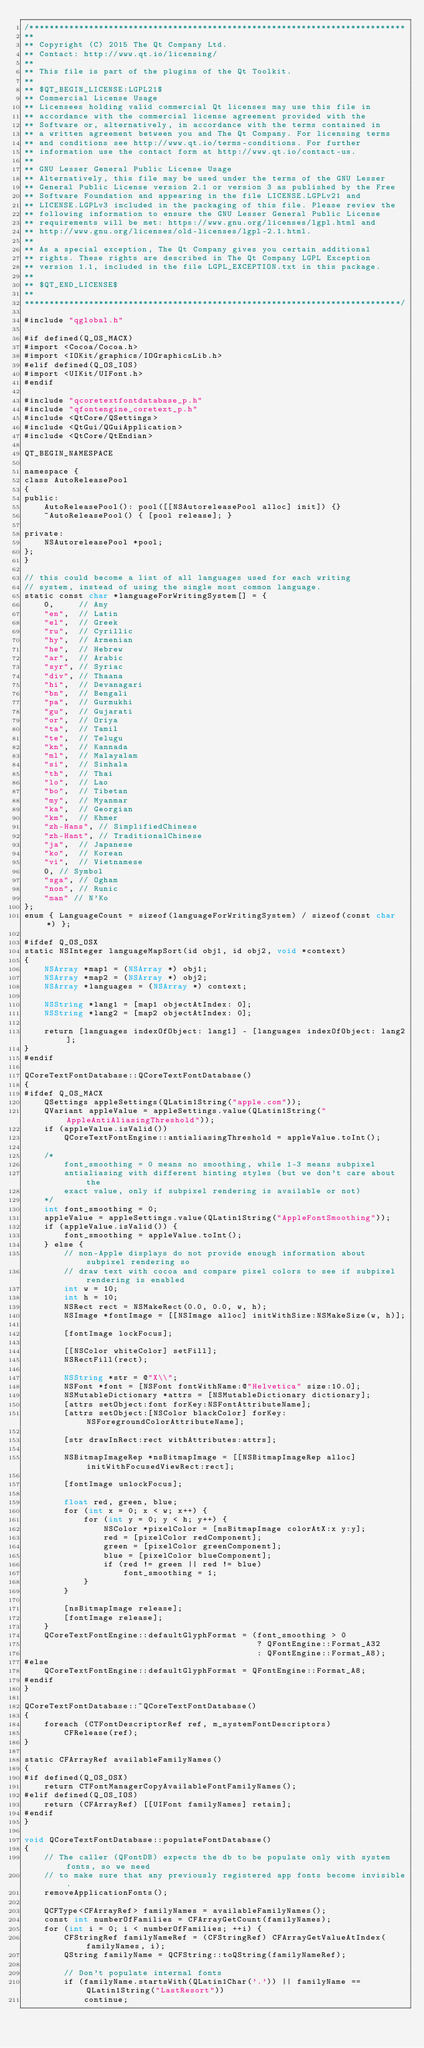Convert code to text. <code><loc_0><loc_0><loc_500><loc_500><_ObjectiveC_>/****************************************************************************
**
** Copyright (C) 2015 The Qt Company Ltd.
** Contact: http://www.qt.io/licensing/
**
** This file is part of the plugins of the Qt Toolkit.
**
** $QT_BEGIN_LICENSE:LGPL21$
** Commercial License Usage
** Licensees holding valid commercial Qt licenses may use this file in
** accordance with the commercial license agreement provided with the
** Software or, alternatively, in accordance with the terms contained in
** a written agreement between you and The Qt Company. For licensing terms
** and conditions see http://www.qt.io/terms-conditions. For further
** information use the contact form at http://www.qt.io/contact-us.
**
** GNU Lesser General Public License Usage
** Alternatively, this file may be used under the terms of the GNU Lesser
** General Public License version 2.1 or version 3 as published by the Free
** Software Foundation and appearing in the file LICENSE.LGPLv21 and
** LICENSE.LGPLv3 included in the packaging of this file. Please review the
** following information to ensure the GNU Lesser General Public License
** requirements will be met: https://www.gnu.org/licenses/lgpl.html and
** http://www.gnu.org/licenses/old-licenses/lgpl-2.1.html.
**
** As a special exception, The Qt Company gives you certain additional
** rights. These rights are described in The Qt Company LGPL Exception
** version 1.1, included in the file LGPL_EXCEPTION.txt in this package.
**
** $QT_END_LICENSE$
**
****************************************************************************/

#include "qglobal.h"

#if defined(Q_OS_MACX)
#import <Cocoa/Cocoa.h>
#import <IOKit/graphics/IOGraphicsLib.h>
#elif defined(Q_OS_IOS)
#import <UIKit/UIFont.h>
#endif

#include "qcoretextfontdatabase_p.h"
#include "qfontengine_coretext_p.h"
#include <QtCore/QSettings>
#include <QtGui/QGuiApplication>
#include <QtCore/QtEndian>

QT_BEGIN_NAMESPACE

namespace {
class AutoReleasePool
{
public:
    AutoReleasePool(): pool([[NSAutoreleasePool alloc] init]) {}
    ~AutoReleasePool() { [pool release]; }

private:
    NSAutoreleasePool *pool;
};
}

// this could become a list of all languages used for each writing
// system, instead of using the single most common language.
static const char *languageForWritingSystem[] = {
    0,     // Any
    "en",  // Latin
    "el",  // Greek
    "ru",  // Cyrillic
    "hy",  // Armenian
    "he",  // Hebrew
    "ar",  // Arabic
    "syr", // Syriac
    "div", // Thaana
    "hi",  // Devanagari
    "bn",  // Bengali
    "pa",  // Gurmukhi
    "gu",  // Gujarati
    "or",  // Oriya
    "ta",  // Tamil
    "te",  // Telugu
    "kn",  // Kannada
    "ml",  // Malayalam
    "si",  // Sinhala
    "th",  // Thai
    "lo",  // Lao
    "bo",  // Tibetan
    "my",  // Myanmar
    "ka",  // Georgian
    "km",  // Khmer
    "zh-Hans", // SimplifiedChinese
    "zh-Hant", // TraditionalChinese
    "ja",  // Japanese
    "ko",  // Korean
    "vi",  // Vietnamese
    0, // Symbol
    "sga", // Ogham
    "non", // Runic
    "man" // N'Ko
};
enum { LanguageCount = sizeof(languageForWritingSystem) / sizeof(const char *) };

#ifdef Q_OS_OSX
static NSInteger languageMapSort(id obj1, id obj2, void *context)
{
    NSArray *map1 = (NSArray *) obj1;
    NSArray *map2 = (NSArray *) obj2;
    NSArray *languages = (NSArray *) context;

    NSString *lang1 = [map1 objectAtIndex: 0];
    NSString *lang2 = [map2 objectAtIndex: 0];

    return [languages indexOfObject: lang1] - [languages indexOfObject: lang2];
}
#endif

QCoreTextFontDatabase::QCoreTextFontDatabase()
{
#ifdef Q_OS_MACX
    QSettings appleSettings(QLatin1String("apple.com"));
    QVariant appleValue = appleSettings.value(QLatin1String("AppleAntiAliasingThreshold"));
    if (appleValue.isValid())
        QCoreTextFontEngine::antialiasingThreshold = appleValue.toInt();

    /*
        font_smoothing = 0 means no smoothing, while 1-3 means subpixel
        antialiasing with different hinting styles (but we don't care about the
        exact value, only if subpixel rendering is available or not)
    */
    int font_smoothing = 0;
    appleValue = appleSettings.value(QLatin1String("AppleFontSmoothing"));
    if (appleValue.isValid()) {
        font_smoothing = appleValue.toInt();
    } else {
        // non-Apple displays do not provide enough information about subpixel rendering so
        // draw text with cocoa and compare pixel colors to see if subpixel rendering is enabled
        int w = 10;
        int h = 10;
        NSRect rect = NSMakeRect(0.0, 0.0, w, h);
        NSImage *fontImage = [[NSImage alloc] initWithSize:NSMakeSize(w, h)];

        [fontImage lockFocus];

        [[NSColor whiteColor] setFill];
        NSRectFill(rect);

        NSString *str = @"X\\";
        NSFont *font = [NSFont fontWithName:@"Helvetica" size:10.0];
        NSMutableDictionary *attrs = [NSMutableDictionary dictionary];
        [attrs setObject:font forKey:NSFontAttributeName];
        [attrs setObject:[NSColor blackColor] forKey:NSForegroundColorAttributeName];

        [str drawInRect:rect withAttributes:attrs];

        NSBitmapImageRep *nsBitmapImage = [[NSBitmapImageRep alloc] initWithFocusedViewRect:rect];

        [fontImage unlockFocus];

        float red, green, blue;
        for (int x = 0; x < w; x++) {
            for (int y = 0; y < h; y++) {
                NSColor *pixelColor = [nsBitmapImage colorAtX:x y:y];
                red = [pixelColor redComponent];
                green = [pixelColor greenComponent];
                blue = [pixelColor blueComponent];
                if (red != green || red != blue)
                    font_smoothing = 1;
            }
        }

        [nsBitmapImage release];
        [fontImage release];
    }
    QCoreTextFontEngine::defaultGlyphFormat = (font_smoothing > 0
                                               ? QFontEngine::Format_A32
                                               : QFontEngine::Format_A8);
#else
    QCoreTextFontEngine::defaultGlyphFormat = QFontEngine::Format_A8;
#endif
}

QCoreTextFontDatabase::~QCoreTextFontDatabase()
{
    foreach (CTFontDescriptorRef ref, m_systemFontDescriptors)
        CFRelease(ref);
}

static CFArrayRef availableFamilyNames()
{
#if defined(Q_OS_OSX)
    return CTFontManagerCopyAvailableFontFamilyNames();
#elif defined(Q_OS_IOS)
    return (CFArrayRef) [[UIFont familyNames] retain];
#endif
}

void QCoreTextFontDatabase::populateFontDatabase()
{
    // The caller (QFontDB) expects the db to be populate only with system fonts, so we need
    // to make sure that any previously registered app fonts become invisible.
    removeApplicationFonts();

    QCFType<CFArrayRef> familyNames = availableFamilyNames();
    const int numberOfFamilies = CFArrayGetCount(familyNames);
    for (int i = 0; i < numberOfFamilies; ++i) {
        CFStringRef familyNameRef = (CFStringRef) CFArrayGetValueAtIndex(familyNames, i);
        QString familyName = QCFString::toQString(familyNameRef);

        // Don't populate internal fonts
        if (familyName.startsWith(QLatin1Char('.')) || familyName == QLatin1String("LastResort"))
            continue;
</code> 